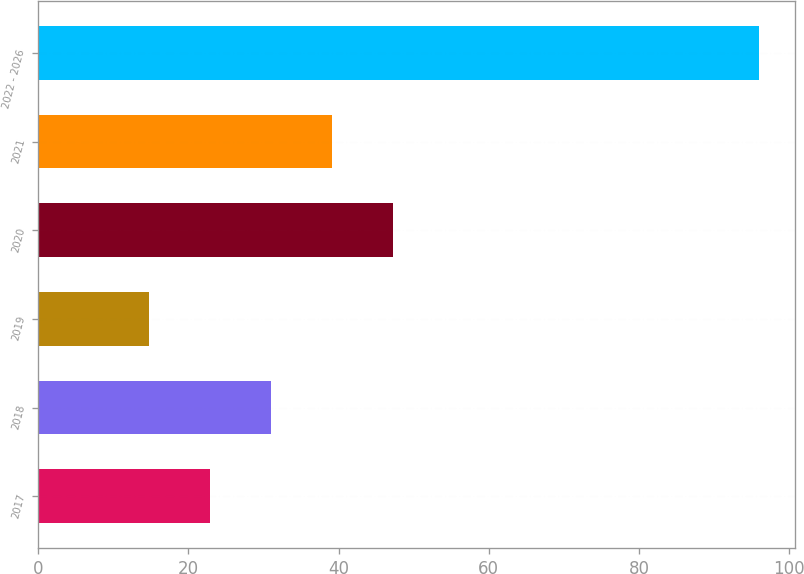Convert chart. <chart><loc_0><loc_0><loc_500><loc_500><bar_chart><fcel>2017<fcel>2018<fcel>2019<fcel>2020<fcel>2021<fcel>2022 - 2026<nl><fcel>22.91<fcel>31.02<fcel>14.8<fcel>47.24<fcel>39.13<fcel>95.9<nl></chart> 